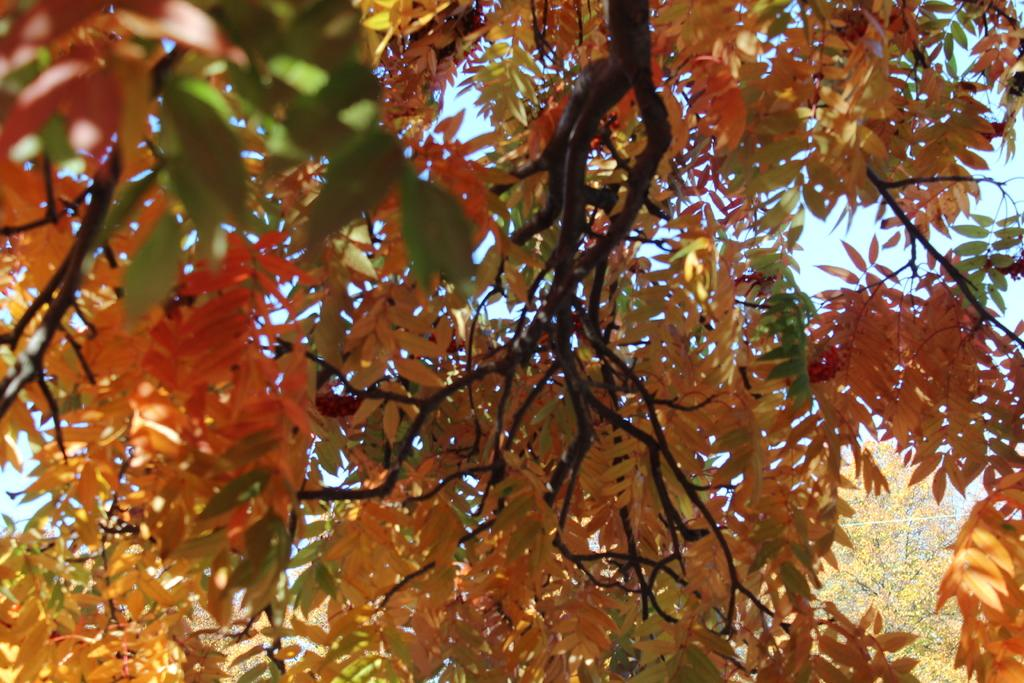Where was the image taken? The image was taken outdoors. What type of natural elements can be seen in the image? There are trees in the image. What can be seen in the background of the image? The sky is visible in the background of the image. What type of property is visible in the image? There is no property visible in the image; it only features trees and the sky. What is the level of friction between the trees and the sky in the image? There is no friction between the trees and the sky in the image, as they are not in contact with each other. 